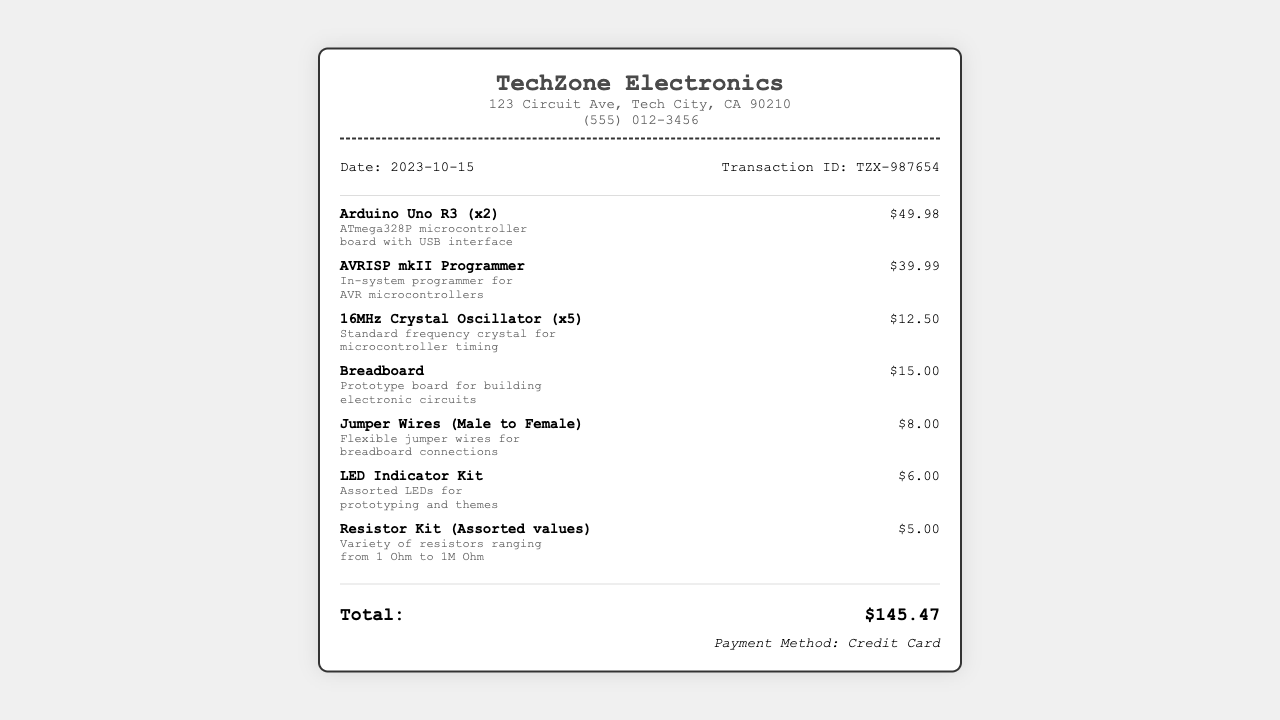What is the store name? The store name is located at the top of the receipt.
Answer: TechZone Electronics What is the transaction ID? The transaction ID is presented in the transaction information section.
Answer: TZX-987654 How many Arduino Uno R3 were purchased? The quantity of Arduino Uno R3 is specified after the item name.
Answer: 2 What is the price of the AVRISP mkII Programmer? The price is listed next to the item name corresponding to the AVRISP mkII Programmer.
Answer: $39.99 What is the total amount spent? The total amount is shown in the total section at the bottom of the receipt.
Answer: $145.47 What date was the transaction made? The date of the transaction is mentioned alongside the transaction ID.
Answer: 2023-10-15 What is the payment method used? The payment method is detailed at the bottom of the receipt.
Answer: Credit Card What item has the description of "Flexible jumper wires for breadboard connections"? The description of items can help identify them on the receipt.
Answer: Jumper Wires (Male to Female) How many 16MHz Crystal Oscillators were included in the purchase? The quantity of the 16MHz Crystal Oscillators is listed next to the item name.
Answer: 5 